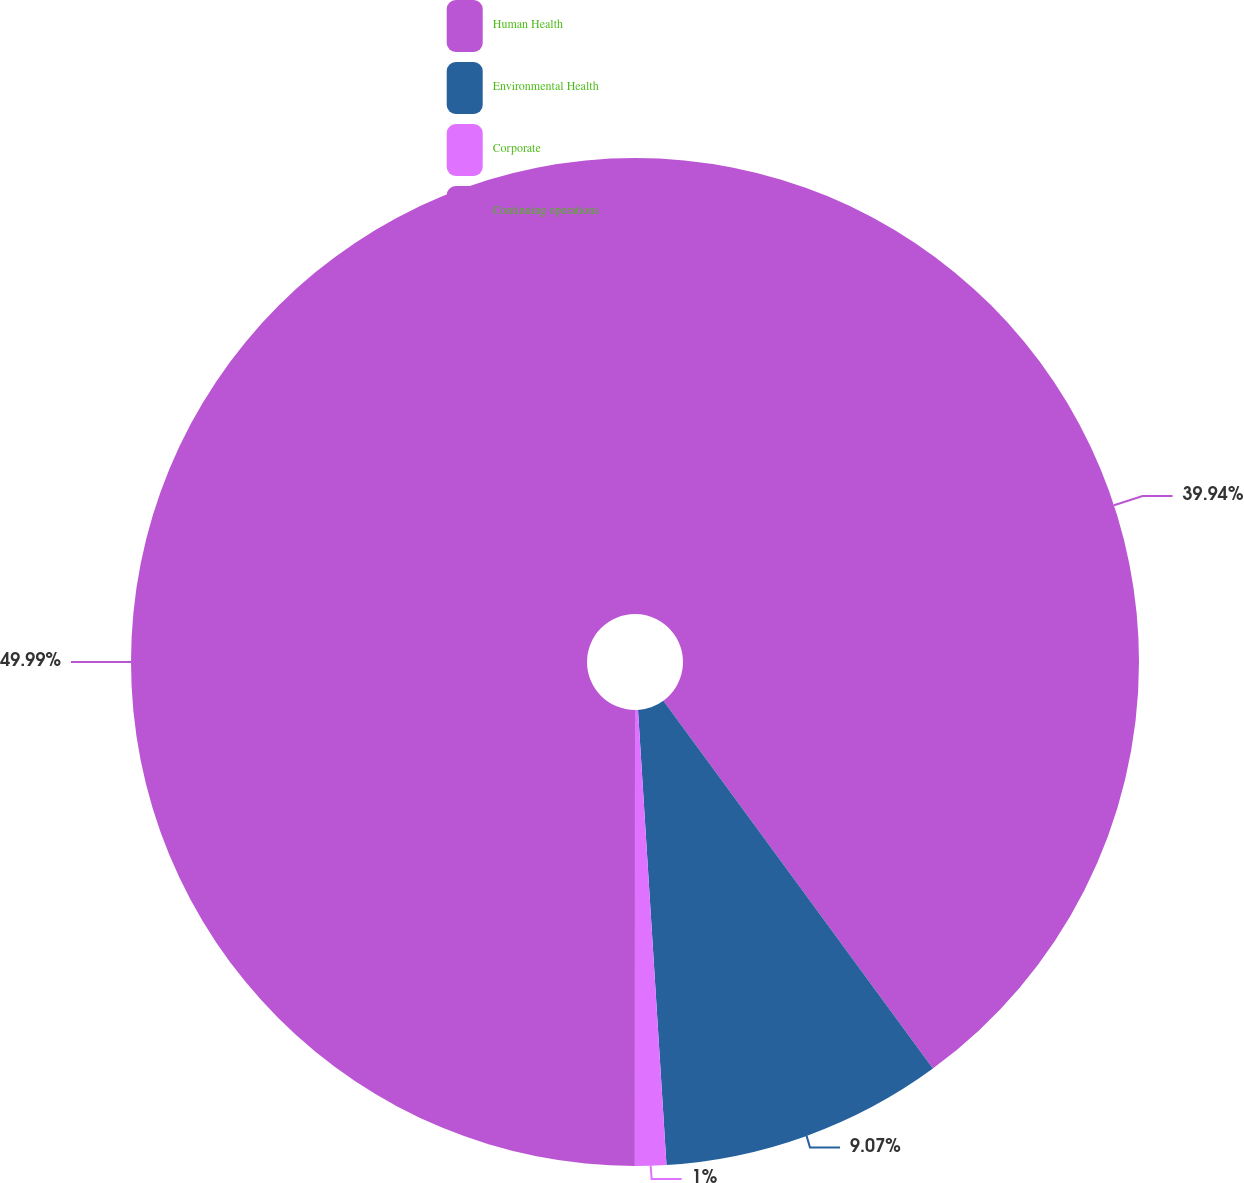Convert chart. <chart><loc_0><loc_0><loc_500><loc_500><pie_chart><fcel>Human Health<fcel>Environmental Health<fcel>Corporate<fcel>Continuing operations<nl><fcel>39.94%<fcel>9.07%<fcel>1.0%<fcel>50.0%<nl></chart> 